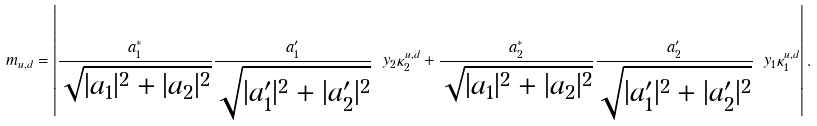<formula> <loc_0><loc_0><loc_500><loc_500>m _ { u , d } = \left | \frac { a _ { 1 } ^ { * } } { \sqrt { | a _ { 1 } | ^ { 2 } + | a _ { 2 } | ^ { 2 } } } \frac { a _ { 1 } ^ { \prime } } { \sqrt { | a _ { 1 } ^ { \prime } | ^ { 2 } + | a _ { 2 } ^ { \prime } | ^ { 2 } } } \ y _ { 2 } \kappa _ { 2 } ^ { u , d } + \frac { a _ { 2 } ^ { * } } { \sqrt { | a _ { 1 } | ^ { 2 } + | a _ { 2 } | ^ { 2 } } } \frac { a _ { 2 } ^ { \prime } } { \sqrt { | a _ { 1 } ^ { \prime } | ^ { 2 } + | a _ { 2 } ^ { \prime } | ^ { 2 } } } \ y _ { 1 } \kappa _ { 1 } ^ { u , d } \right | .</formula> 